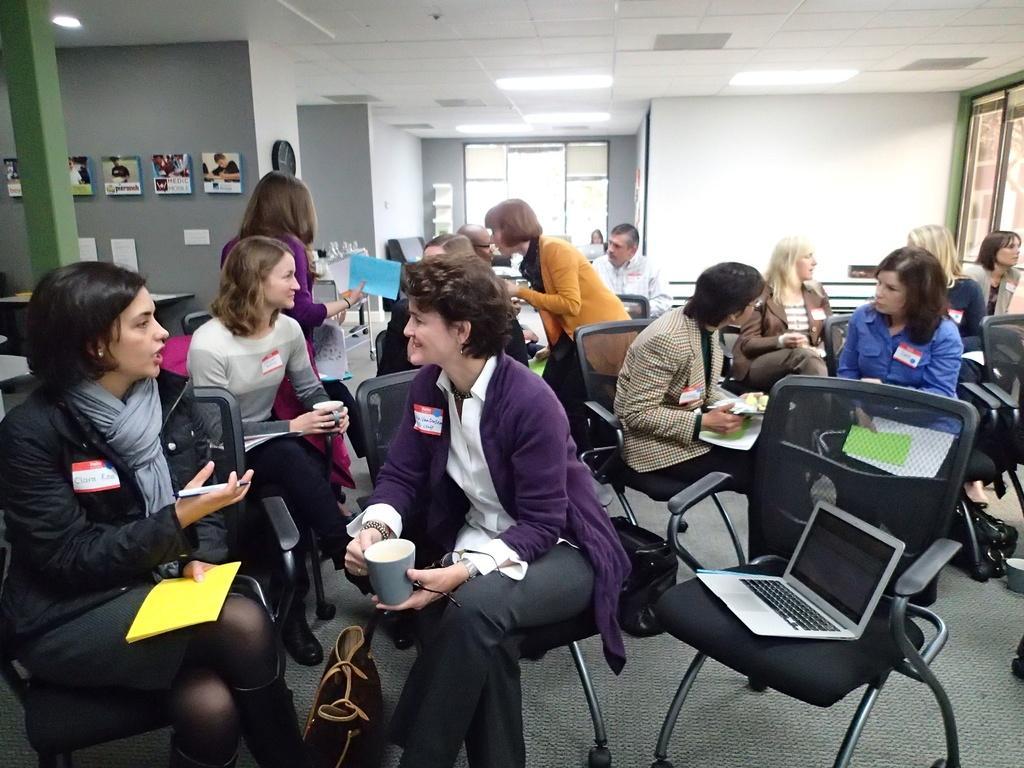Please provide a concise description of this image. In this image, group of people are sat on the chair. Few are holding some papers, some items. Dew are talking with the others, few are smiling. The background we can see white color wall, windows, some photo frames, green pillar, tables ,few items are placed on it. The bottom, we can see a bag and right side there is a laptop. 